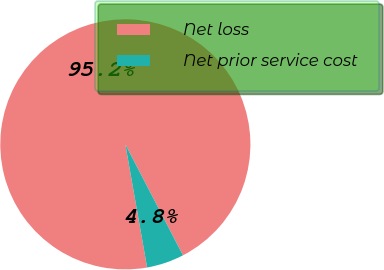<chart> <loc_0><loc_0><loc_500><loc_500><pie_chart><fcel>Net loss<fcel>Net prior service cost<nl><fcel>95.16%<fcel>4.84%<nl></chart> 